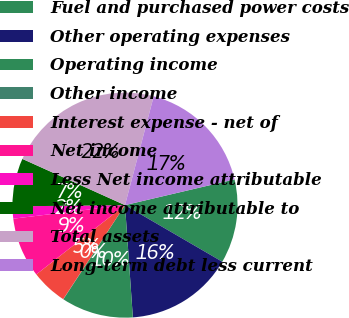<chart> <loc_0><loc_0><loc_500><loc_500><pie_chart><fcel>Fuel and purchased power costs<fcel>Other operating expenses<fcel>Operating income<fcel>Other income<fcel>Interest expense - net of<fcel>Net income<fcel>Less Net income attributable<fcel>Net income attributable to<fcel>Total assets<fcel>Long-term debt less current<nl><fcel>12.06%<fcel>15.5%<fcel>10.34%<fcel>0.03%<fcel>5.19%<fcel>8.63%<fcel>1.75%<fcel>6.91%<fcel>22.37%<fcel>17.22%<nl></chart> 